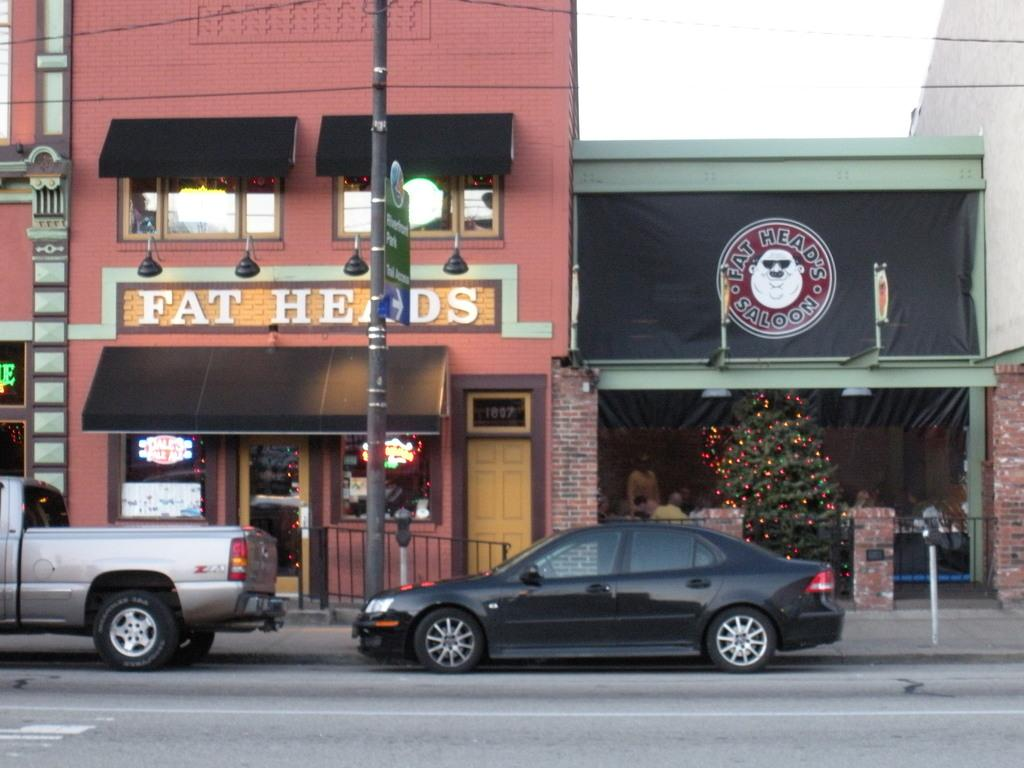<image>
Share a concise interpretation of the image provided. a shot of the outside of Fat Heads Saloom 